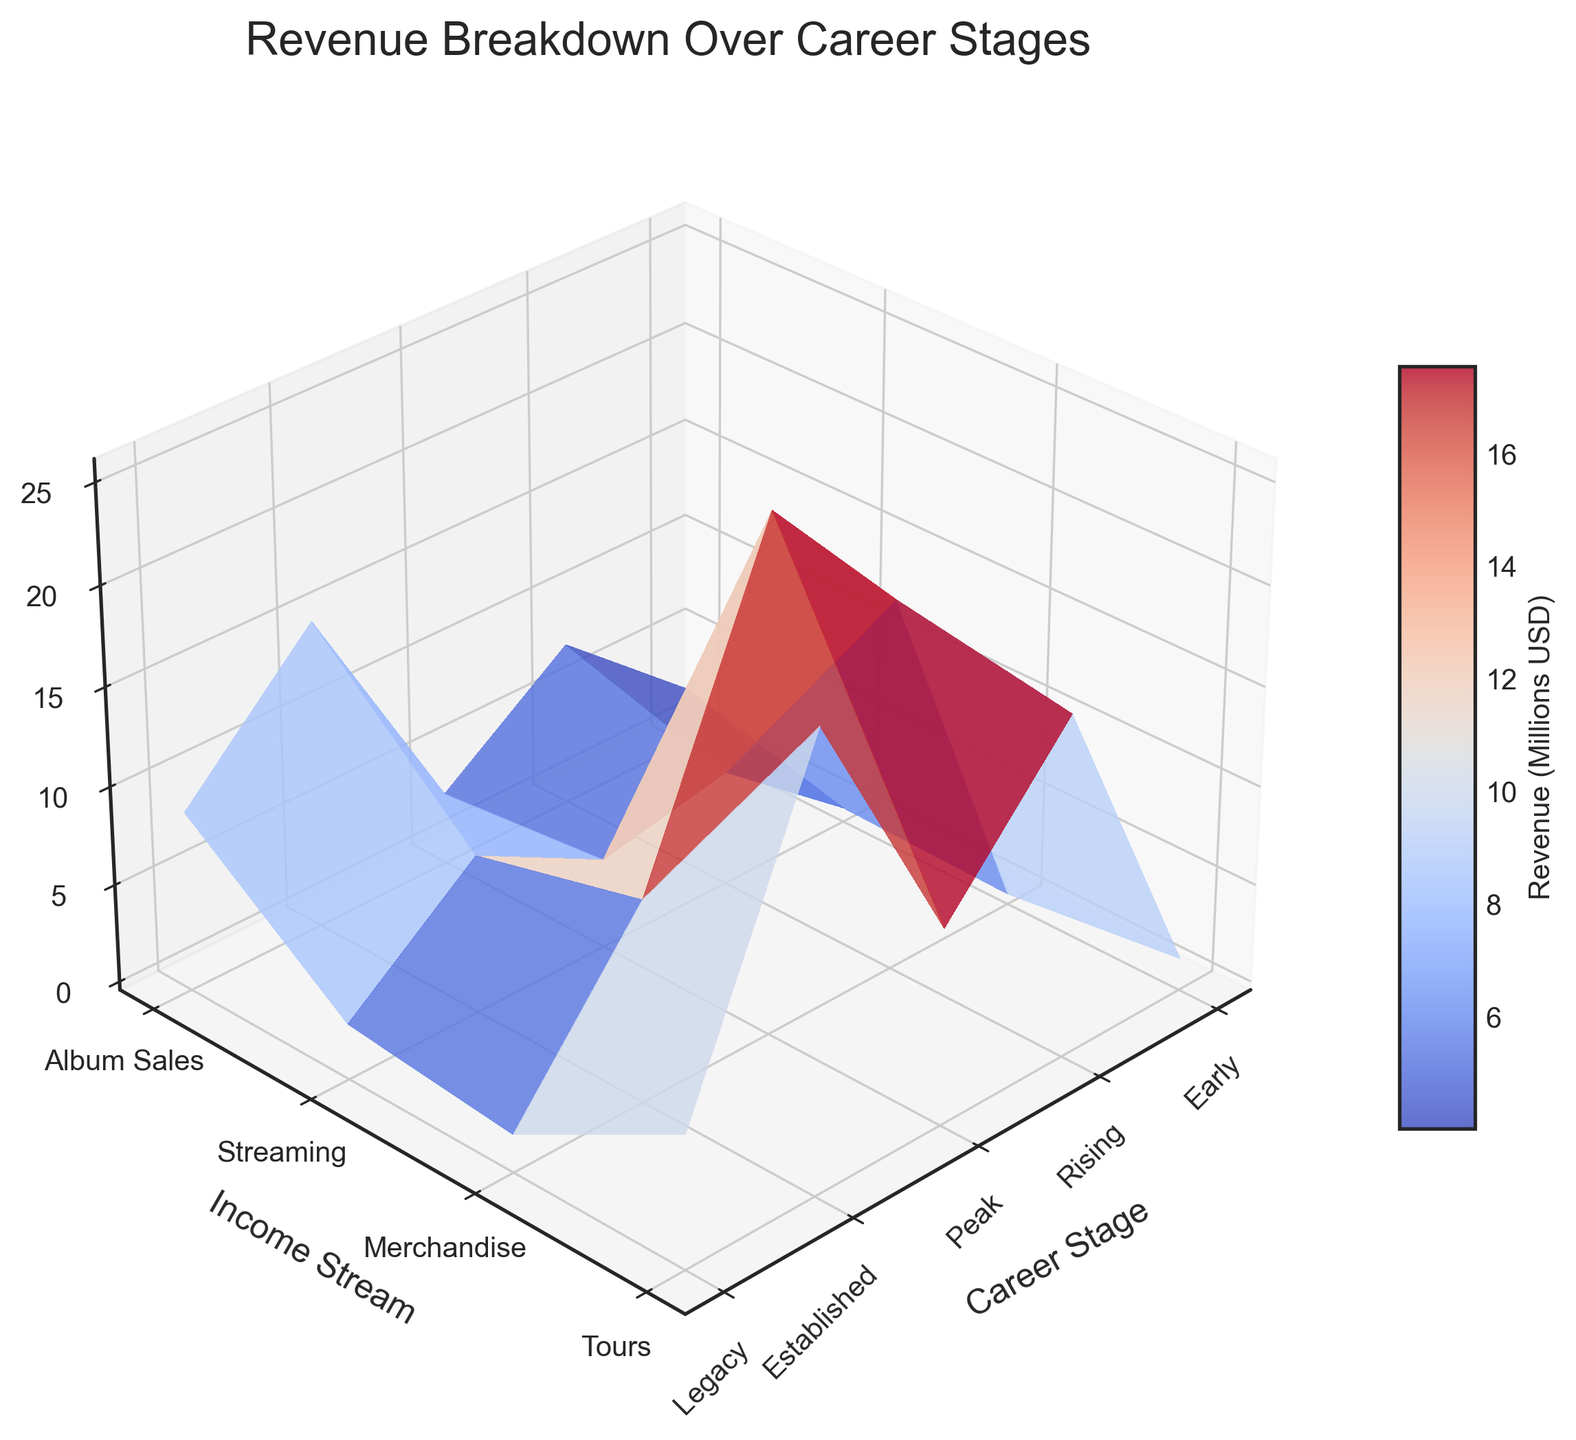What's the title of the figure? The title is usually displayed at the top of the figure. In this case, it's centered and reads "Revenue Breakdown Over Career Stages".
Answer: Revenue Breakdown Over Career Stages What are the labels on the axes? The x-axis is labeled "Career Stage", the y-axis is labeled "Income Stream", and the z-axis is labeled "Revenue (Millions USD)".
Answer: Career Stage, Income Stream, Revenue (Millions USD) Which income stream generates the highest revenue at the peak career stage? By looking at the highest data point on the surface for the peak stage, we can see that "Tours" has the highest peak.
Answer: Tours How does the revenue from streaming change from early to legacy stages? Starting at the low revenue in the early stage, the surface for streaming revenue increases gradually, peaking in the legacy stage.
Answer: It increases significantly Which career stage sees the highest overall revenue? By observing the highest points on the surface corresponding to different career stages, we notice that the peak stage has the highest revenue values.
Answer: Peak How many income streams are represented in this plot? By counting the y-axis tick labels, we find that there are four income streams: Album Sales, Streaming, Merchandise, and Tours.
Answer: 4 In which career stage do album sales reach their maximum? The highest point on the surface for the album sales income stream occurs during the peak stage.
Answer: Peak What is the overall trend in revenue from merchandise as the career progresses? The revenue from merchandise increases from early to peak stages and then decreases slightly in the established and legacy stages.
Answer: Increases then decreases Which has more revenue in the legacy stage, merchandise or tours? By comparing the heights of the surfaces at the legacy stage for merchandise and tours, tours have a higher surface.
Answer: Tours Compare the revenue from streaming in the rising stage to merchandise in the established stage. Observing the surface height at these two points shows that streaming in the rising stage (1.5 million USD) is less than merchandise in the established stage (5.4 million USD).
Answer: Merchandise in the established stage has more revenue 